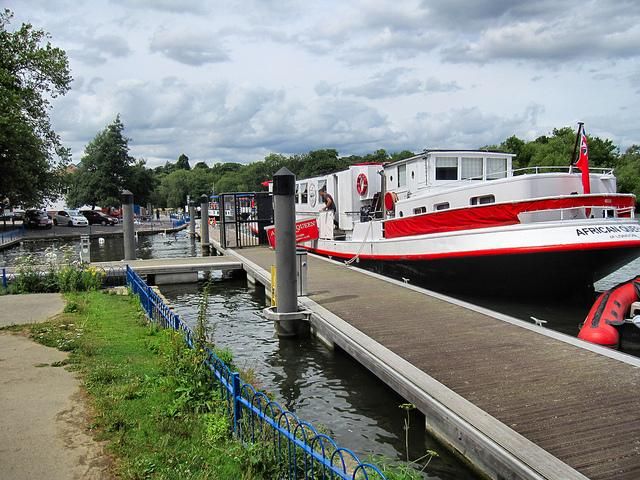What's the term for how this boat is parked?

Choices:
A) docked
B) waiting
C) anchored
D) setting docked 